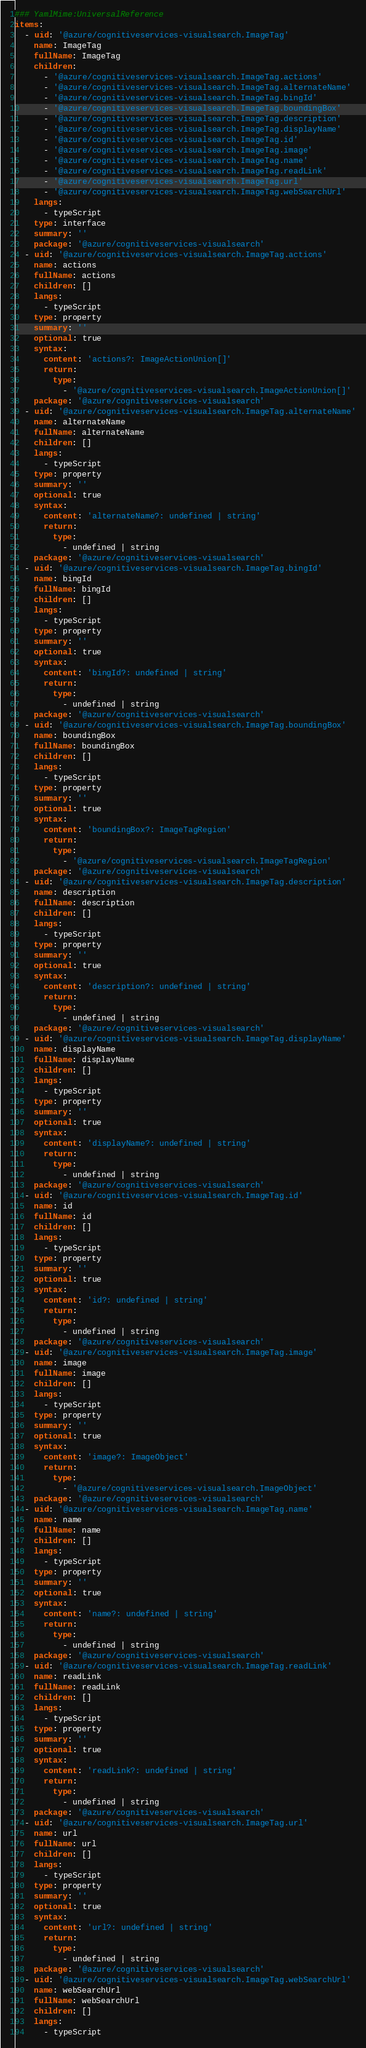Convert code to text. <code><loc_0><loc_0><loc_500><loc_500><_YAML_>### YamlMime:UniversalReference
items:
  - uid: '@azure/cognitiveservices-visualsearch.ImageTag'
    name: ImageTag
    fullName: ImageTag
    children:
      - '@azure/cognitiveservices-visualsearch.ImageTag.actions'
      - '@azure/cognitiveservices-visualsearch.ImageTag.alternateName'
      - '@azure/cognitiveservices-visualsearch.ImageTag.bingId'
      - '@azure/cognitiveservices-visualsearch.ImageTag.boundingBox'
      - '@azure/cognitiveservices-visualsearch.ImageTag.description'
      - '@azure/cognitiveservices-visualsearch.ImageTag.displayName'
      - '@azure/cognitiveservices-visualsearch.ImageTag.id'
      - '@azure/cognitiveservices-visualsearch.ImageTag.image'
      - '@azure/cognitiveservices-visualsearch.ImageTag.name'
      - '@azure/cognitiveservices-visualsearch.ImageTag.readLink'
      - '@azure/cognitiveservices-visualsearch.ImageTag.url'
      - '@azure/cognitiveservices-visualsearch.ImageTag.webSearchUrl'
    langs:
      - typeScript
    type: interface
    summary: ''
    package: '@azure/cognitiveservices-visualsearch'
  - uid: '@azure/cognitiveservices-visualsearch.ImageTag.actions'
    name: actions
    fullName: actions
    children: []
    langs:
      - typeScript
    type: property
    summary: ''
    optional: true
    syntax:
      content: 'actions?: ImageActionUnion[]'
      return:
        type:
          - '@azure/cognitiveservices-visualsearch.ImageActionUnion[]'
    package: '@azure/cognitiveservices-visualsearch'
  - uid: '@azure/cognitiveservices-visualsearch.ImageTag.alternateName'
    name: alternateName
    fullName: alternateName
    children: []
    langs:
      - typeScript
    type: property
    summary: ''
    optional: true
    syntax:
      content: 'alternateName?: undefined | string'
      return:
        type:
          - undefined | string
    package: '@azure/cognitiveservices-visualsearch'
  - uid: '@azure/cognitiveservices-visualsearch.ImageTag.bingId'
    name: bingId
    fullName: bingId
    children: []
    langs:
      - typeScript
    type: property
    summary: ''
    optional: true
    syntax:
      content: 'bingId?: undefined | string'
      return:
        type:
          - undefined | string
    package: '@azure/cognitiveservices-visualsearch'
  - uid: '@azure/cognitiveservices-visualsearch.ImageTag.boundingBox'
    name: boundingBox
    fullName: boundingBox
    children: []
    langs:
      - typeScript
    type: property
    summary: ''
    optional: true
    syntax:
      content: 'boundingBox?: ImageTagRegion'
      return:
        type:
          - '@azure/cognitiveservices-visualsearch.ImageTagRegion'
    package: '@azure/cognitiveservices-visualsearch'
  - uid: '@azure/cognitiveservices-visualsearch.ImageTag.description'
    name: description
    fullName: description
    children: []
    langs:
      - typeScript
    type: property
    summary: ''
    optional: true
    syntax:
      content: 'description?: undefined | string'
      return:
        type:
          - undefined | string
    package: '@azure/cognitiveservices-visualsearch'
  - uid: '@azure/cognitiveservices-visualsearch.ImageTag.displayName'
    name: displayName
    fullName: displayName
    children: []
    langs:
      - typeScript
    type: property
    summary: ''
    optional: true
    syntax:
      content: 'displayName?: undefined | string'
      return:
        type:
          - undefined | string
    package: '@azure/cognitiveservices-visualsearch'
  - uid: '@azure/cognitiveservices-visualsearch.ImageTag.id'
    name: id
    fullName: id
    children: []
    langs:
      - typeScript
    type: property
    summary: ''
    optional: true
    syntax:
      content: 'id?: undefined | string'
      return:
        type:
          - undefined | string
    package: '@azure/cognitiveservices-visualsearch'
  - uid: '@azure/cognitiveservices-visualsearch.ImageTag.image'
    name: image
    fullName: image
    children: []
    langs:
      - typeScript
    type: property
    summary: ''
    optional: true
    syntax:
      content: 'image?: ImageObject'
      return:
        type:
          - '@azure/cognitiveservices-visualsearch.ImageObject'
    package: '@azure/cognitiveservices-visualsearch'
  - uid: '@azure/cognitiveservices-visualsearch.ImageTag.name'
    name: name
    fullName: name
    children: []
    langs:
      - typeScript
    type: property
    summary: ''
    optional: true
    syntax:
      content: 'name?: undefined | string'
      return:
        type:
          - undefined | string
    package: '@azure/cognitiveservices-visualsearch'
  - uid: '@azure/cognitiveservices-visualsearch.ImageTag.readLink'
    name: readLink
    fullName: readLink
    children: []
    langs:
      - typeScript
    type: property
    summary: ''
    optional: true
    syntax:
      content: 'readLink?: undefined | string'
      return:
        type:
          - undefined | string
    package: '@azure/cognitiveservices-visualsearch'
  - uid: '@azure/cognitiveservices-visualsearch.ImageTag.url'
    name: url
    fullName: url
    children: []
    langs:
      - typeScript
    type: property
    summary: ''
    optional: true
    syntax:
      content: 'url?: undefined | string'
      return:
        type:
          - undefined | string
    package: '@azure/cognitiveservices-visualsearch'
  - uid: '@azure/cognitiveservices-visualsearch.ImageTag.webSearchUrl'
    name: webSearchUrl
    fullName: webSearchUrl
    children: []
    langs:
      - typeScript</code> 